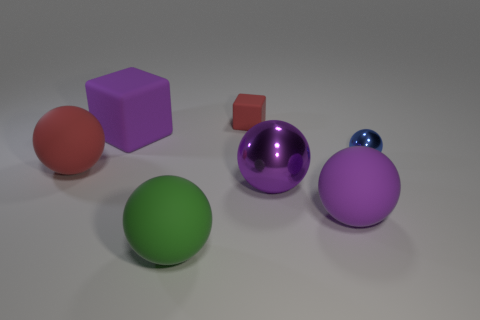What is the color of the tiny thing that is the same shape as the big red rubber object? blue 